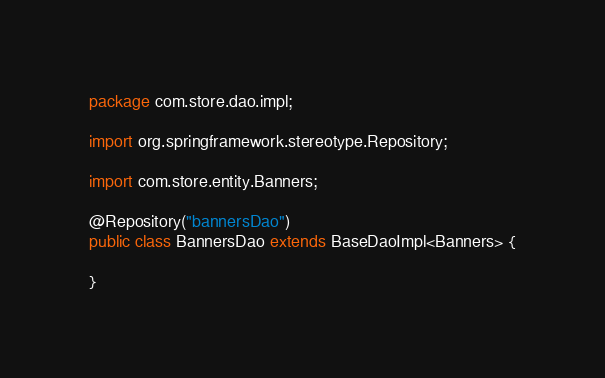<code> <loc_0><loc_0><loc_500><loc_500><_Java_>package com.store.dao.impl;

import org.springframework.stereotype.Repository;

import com.store.entity.Banners;

@Repository("bannersDao")
public class BannersDao extends BaseDaoImpl<Banners> {

}
</code> 